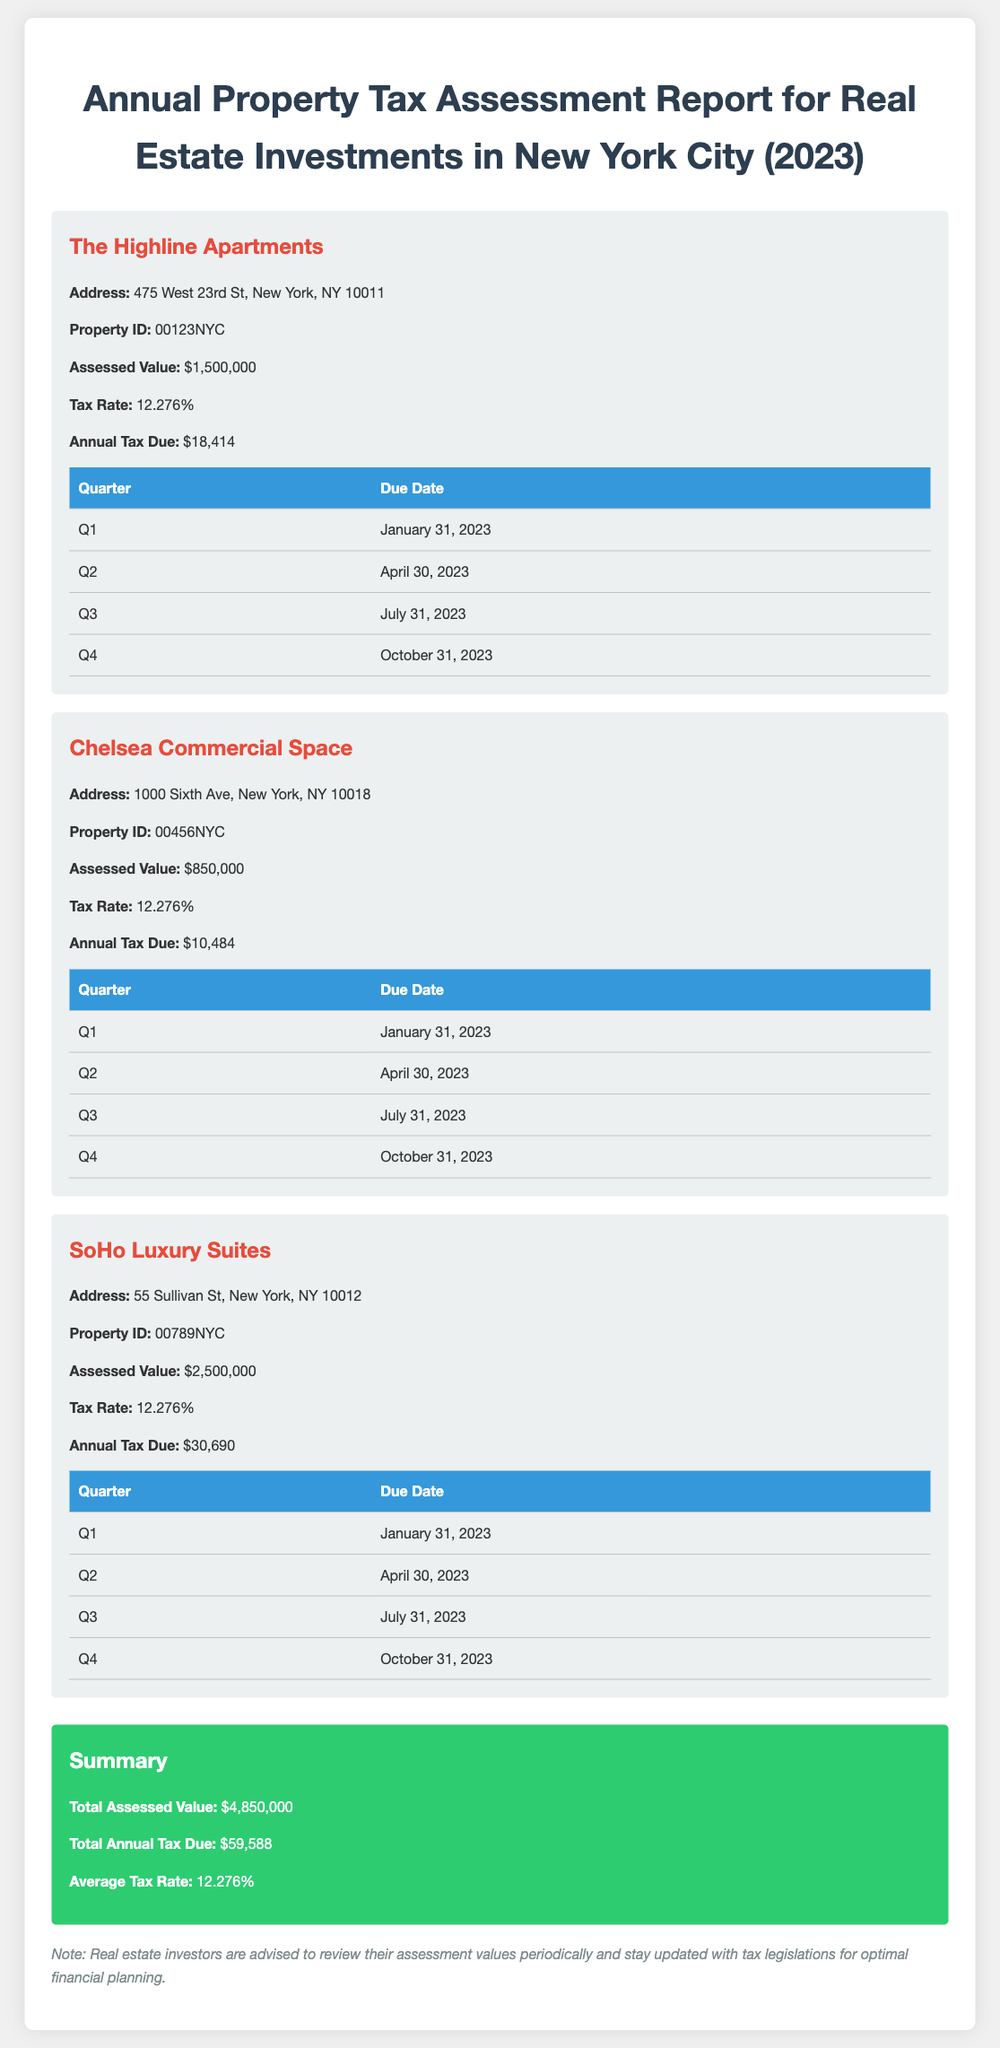What is the assessed value of The Highline Apartments? The assessed value of The Highline Apartments is specified directly in the report.
Answer: $1,500,000 What is the tax rate for Chelsea Commercial Space? The tax rate for Chelsea Commercial Space is mentioned in the document.
Answer: 12.276% When is the annual tax due for SoHo Luxury Suites? The annual tax due for SoHo Luxury Suites is calculated from its assessed value and tax rate, stated in the report.
Answer: $30,690 What is the total assessed value of all properties listed in the report? The total assessed value is the sum of the assessed values of all listed properties in the summary section.
Answer: $4,850,000 How many quarters are there for tax payments in a year according to the report? The report outlines tax payment due dates for each quarter, providing direct information about the number of quarters.
Answer: 4 What is the due date for the first quarter tax payment? The due date for the first quarter tax payment is listed in the property sections of the report.
Answer: January 31, 2023 What is the average tax rate mentioned in the report? The average tax rate is specified in the summary section of the report, combining the rates of the listed properties.
Answer: 12.276% How much is the annual tax due for Chelsea Commercial Space? The document provides the annual tax amount for Chelsea Commercial Space, as shown in its individual property section.
Answer: $10,484 What property has the highest assessed value in the report? By comparing the assessed values of each property listed, we can identify which has the highest value.
Answer: SoHo Luxury Suites 